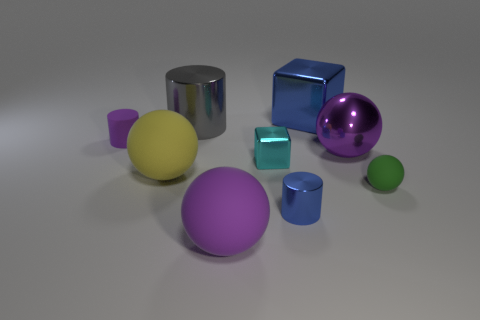Add 1 purple rubber cylinders. How many objects exist? 10 Subtract all blocks. How many objects are left? 7 Add 2 small shiny cylinders. How many small shiny cylinders exist? 3 Subtract 0 brown cylinders. How many objects are left? 9 Subtract all cyan cubes. Subtract all metal objects. How many objects are left? 3 Add 5 yellow rubber spheres. How many yellow rubber spheres are left? 6 